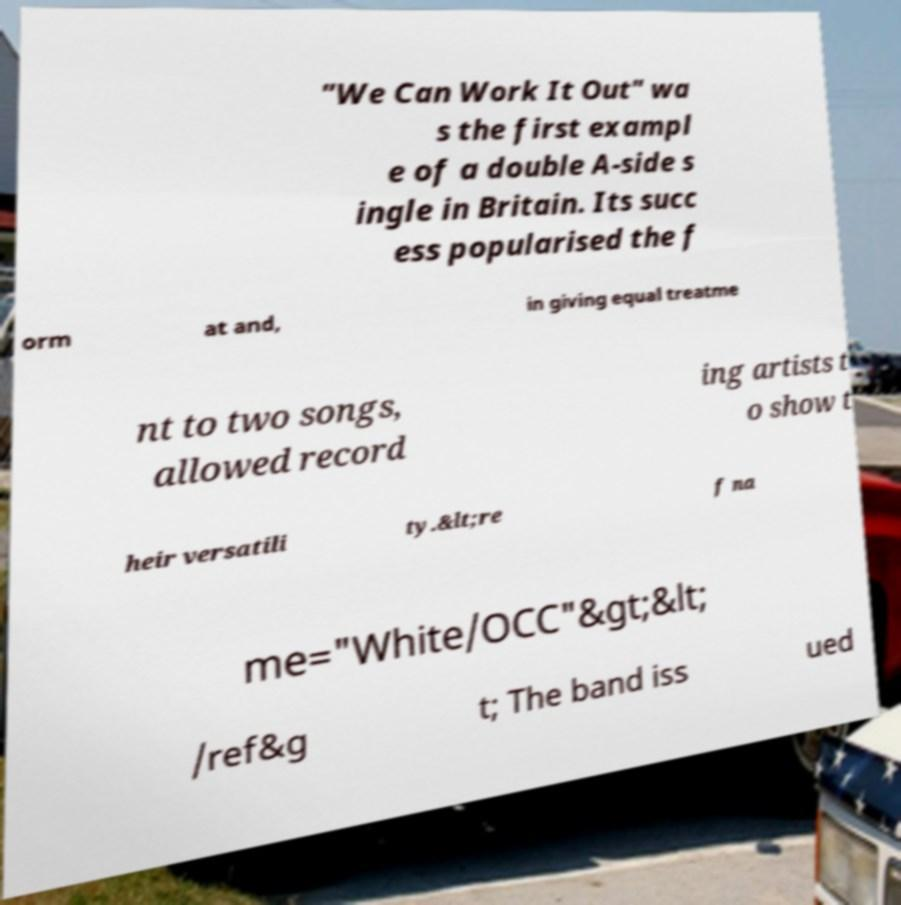For documentation purposes, I need the text within this image transcribed. Could you provide that? "We Can Work It Out" wa s the first exampl e of a double A-side s ingle in Britain. Its succ ess popularised the f orm at and, in giving equal treatme nt to two songs, allowed record ing artists t o show t heir versatili ty.&lt;re f na me="White/OCC"&gt;&lt; /ref&g t; The band iss ued 